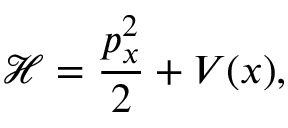Convert formula to latex. <formula><loc_0><loc_0><loc_500><loc_500>\mathcal { H } = \frac { p _ { x } ^ { 2 } } { 2 } + V ( x ) ,</formula> 